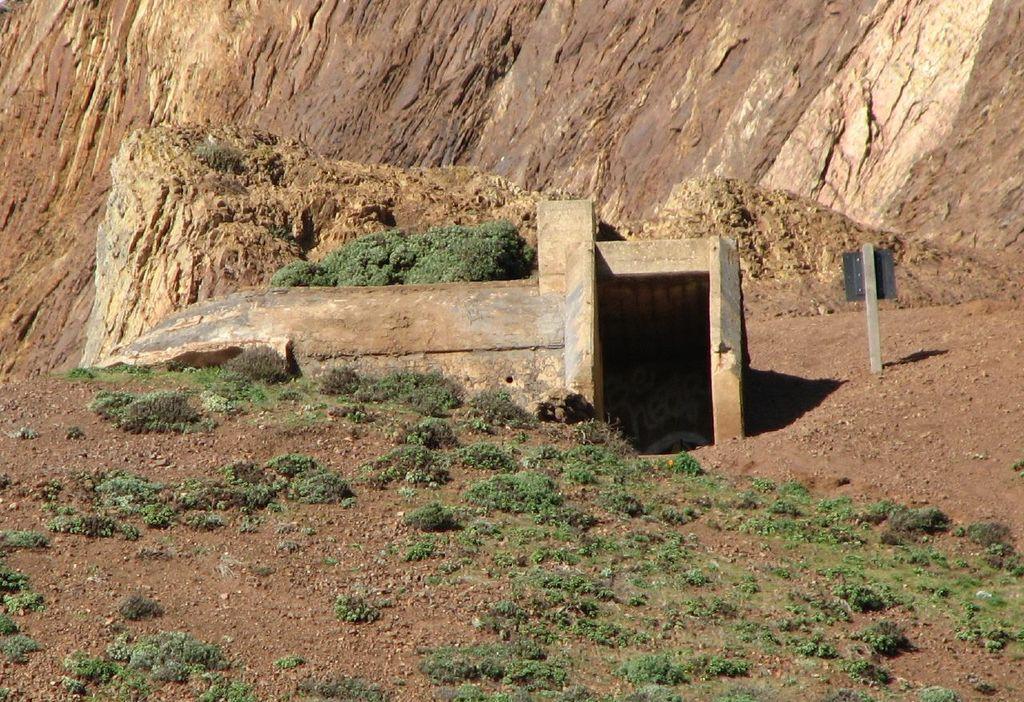Could you give a brief overview of what you see in this image? In this picture we can see planets hill and it is looking like an architecture. 